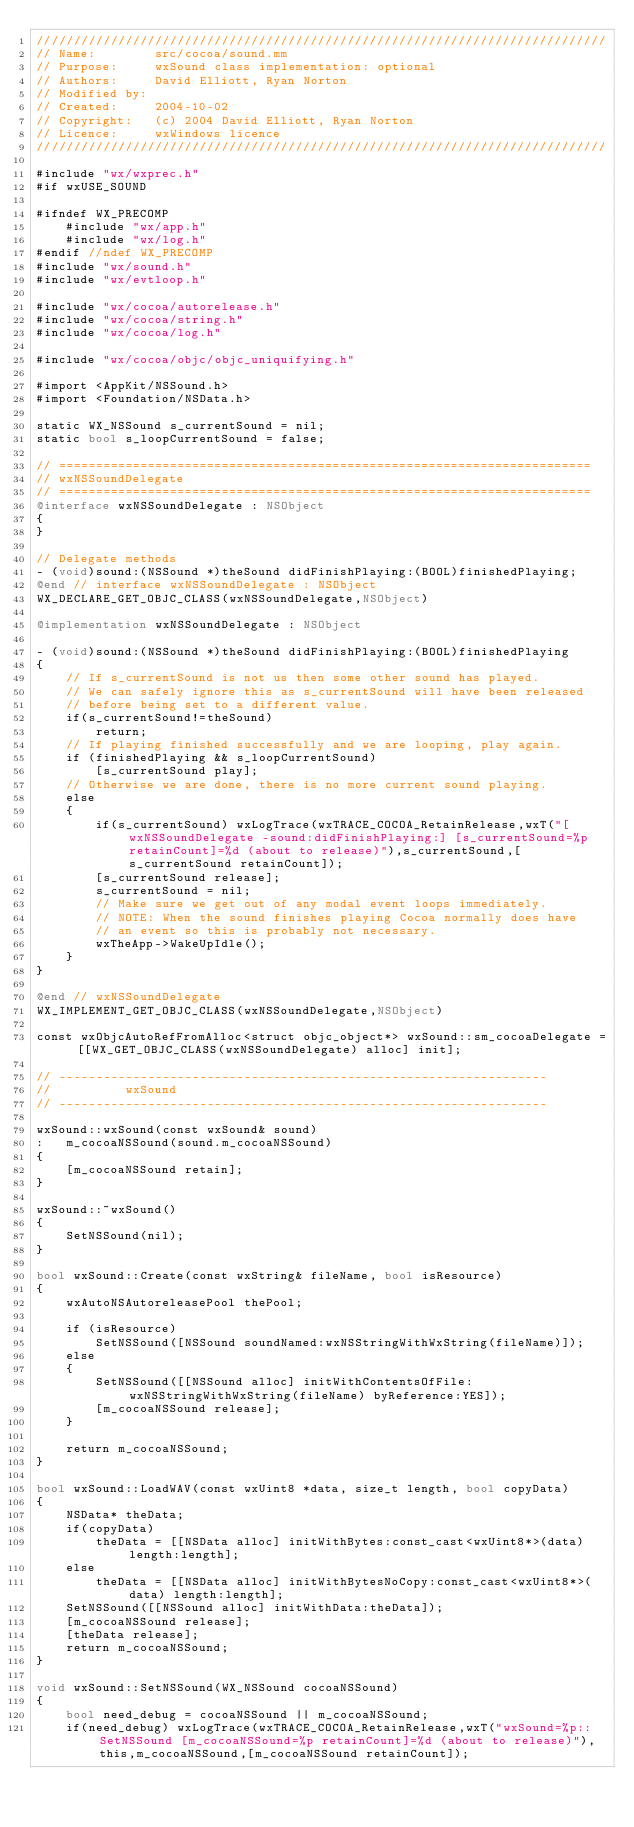<code> <loc_0><loc_0><loc_500><loc_500><_ObjectiveC_>/////////////////////////////////////////////////////////////////////////////
// Name:        src/cocoa/sound.mm
// Purpose:     wxSound class implementation: optional
// Authors:     David Elliott, Ryan Norton
// Modified by: 
// Created:     2004-10-02
// Copyright:   (c) 2004 David Elliott, Ryan Norton
// Licence:     wxWindows licence
/////////////////////////////////////////////////////////////////////////////

#include "wx/wxprec.h"
#if wxUSE_SOUND

#ifndef WX_PRECOMP
    #include "wx/app.h"
    #include "wx/log.h"
#endif //ndef WX_PRECOMP
#include "wx/sound.h"
#include "wx/evtloop.h"

#include "wx/cocoa/autorelease.h"
#include "wx/cocoa/string.h"
#include "wx/cocoa/log.h"

#include "wx/cocoa/objc/objc_uniquifying.h"

#import <AppKit/NSSound.h>
#import <Foundation/NSData.h>

static WX_NSSound s_currentSound = nil;
static bool s_loopCurrentSound = false;

// ========================================================================
// wxNSSoundDelegate
// ========================================================================
@interface wxNSSoundDelegate : NSObject
{
}

// Delegate methods
- (void)sound:(NSSound *)theSound didFinishPlaying:(BOOL)finishedPlaying;
@end // interface wxNSSoundDelegate : NSObject
WX_DECLARE_GET_OBJC_CLASS(wxNSSoundDelegate,NSObject)

@implementation wxNSSoundDelegate : NSObject

- (void)sound:(NSSound *)theSound didFinishPlaying:(BOOL)finishedPlaying
{
    // If s_currentSound is not us then some other sound has played.
    // We can safely ignore this as s_currentSound will have been released
    // before being set to a different value.
    if(s_currentSound!=theSound)
        return;
    // If playing finished successfully and we are looping, play again.
    if (finishedPlaying && s_loopCurrentSound)
        [s_currentSound play];
    // Otherwise we are done, there is no more current sound playing.
    else
    {
        if(s_currentSound) wxLogTrace(wxTRACE_COCOA_RetainRelease,wxT("[wxNSSoundDelegate -sound:didFinishPlaying:] [s_currentSound=%p retainCount]=%d (about to release)"),s_currentSound,[s_currentSound retainCount]);
        [s_currentSound release];
        s_currentSound = nil;
        // Make sure we get out of any modal event loops immediately.
        // NOTE: When the sound finishes playing Cocoa normally does have
        // an event so this is probably not necessary.
        wxTheApp->WakeUpIdle();
    }
}

@end // wxNSSoundDelegate
WX_IMPLEMENT_GET_OBJC_CLASS(wxNSSoundDelegate,NSObject)

const wxObjcAutoRefFromAlloc<struct objc_object*> wxSound::sm_cocoaDelegate = [[WX_GET_OBJC_CLASS(wxNSSoundDelegate) alloc] init];

// ------------------------------------------------------------------
//          wxSound
// ------------------------------------------------------------------

wxSound::wxSound(const wxSound& sound)
:   m_cocoaNSSound(sound.m_cocoaNSSound)
{
    [m_cocoaNSSound retain];
}

wxSound::~wxSound()
{
    SetNSSound(nil);
}

bool wxSound::Create(const wxString& fileName, bool isResource)
{
    wxAutoNSAutoreleasePool thePool;

    if (isResource)
        SetNSSound([NSSound soundNamed:wxNSStringWithWxString(fileName)]);
    else
    {
        SetNSSound([[NSSound alloc] initWithContentsOfFile:wxNSStringWithWxString(fileName) byReference:YES]);
        [m_cocoaNSSound release];
    }

    return m_cocoaNSSound;
}

bool wxSound::LoadWAV(const wxUint8 *data, size_t length, bool copyData)
{
    NSData* theData;
    if(copyData)
        theData = [[NSData alloc] initWithBytes:const_cast<wxUint8*>(data) length:length];
    else
        theData = [[NSData alloc] initWithBytesNoCopy:const_cast<wxUint8*>(data) length:length];
    SetNSSound([[NSSound alloc] initWithData:theData]);
    [m_cocoaNSSound release];
    [theData release];
    return m_cocoaNSSound;
}

void wxSound::SetNSSound(WX_NSSound cocoaNSSound)
{
    bool need_debug = cocoaNSSound || m_cocoaNSSound;
    if(need_debug) wxLogTrace(wxTRACE_COCOA_RetainRelease,wxT("wxSound=%p::SetNSSound [m_cocoaNSSound=%p retainCount]=%d (about to release)"),this,m_cocoaNSSound,[m_cocoaNSSound retainCount]);</code> 